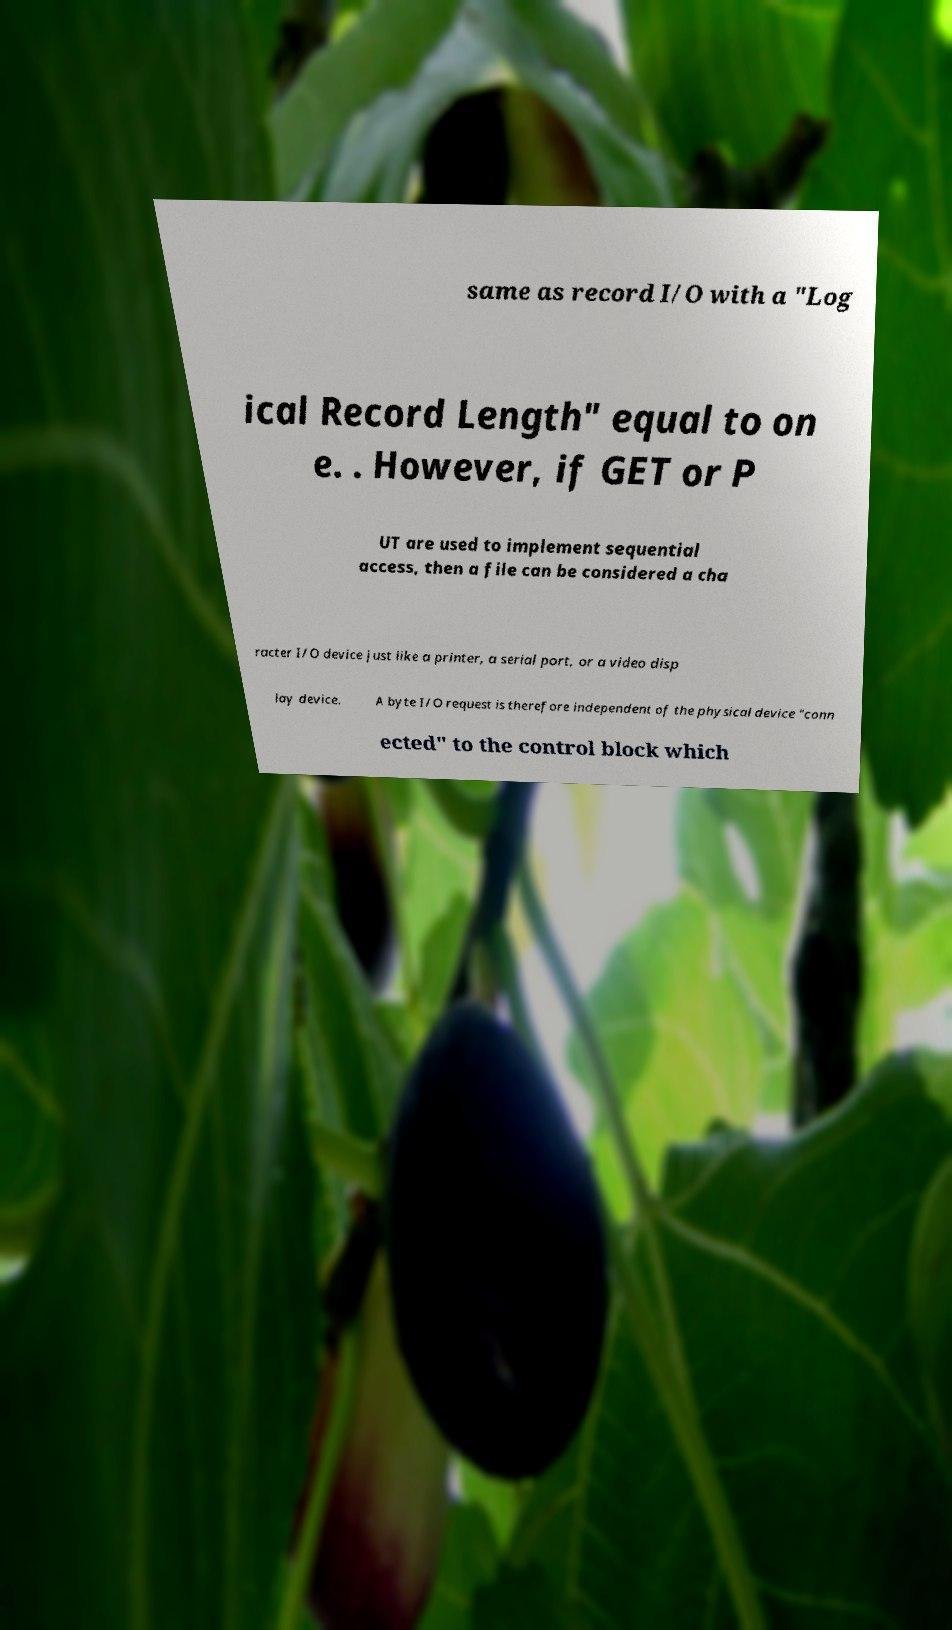Can you accurately transcribe the text from the provided image for me? same as record I/O with a "Log ical Record Length" equal to on e. . However, if GET or P UT are used to implement sequential access, then a file can be considered a cha racter I/O device just like a printer, a serial port, or a video disp lay device. A byte I/O request is therefore independent of the physical device "conn ected" to the control block which 